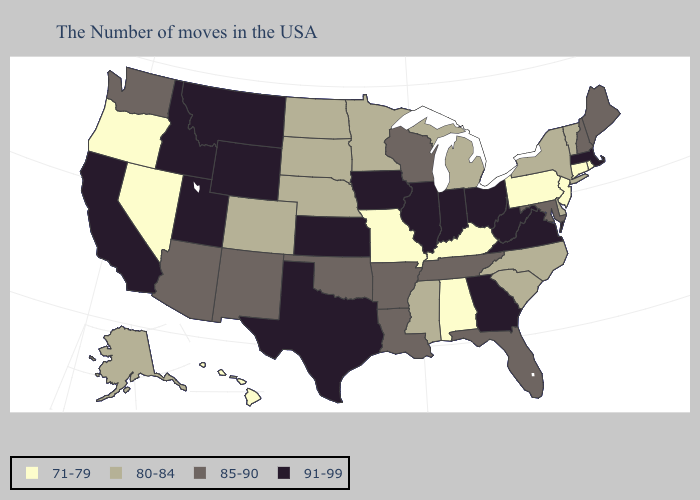Does Hawaii have the lowest value in the West?
Keep it brief. Yes. Does Texas have the lowest value in the USA?
Short answer required. No. Among the states that border Virginia , does West Virginia have the highest value?
Concise answer only. Yes. Among the states that border New Mexico , does Utah have the highest value?
Write a very short answer. Yes. Name the states that have a value in the range 91-99?
Concise answer only. Massachusetts, Virginia, West Virginia, Ohio, Georgia, Indiana, Illinois, Iowa, Kansas, Texas, Wyoming, Utah, Montana, Idaho, California. Name the states that have a value in the range 91-99?
Short answer required. Massachusetts, Virginia, West Virginia, Ohio, Georgia, Indiana, Illinois, Iowa, Kansas, Texas, Wyoming, Utah, Montana, Idaho, California. What is the value of South Dakota?
Answer briefly. 80-84. Among the states that border Indiana , which have the lowest value?
Write a very short answer. Kentucky. What is the value of New Hampshire?
Quick response, please. 85-90. What is the value of Delaware?
Keep it brief. 80-84. What is the lowest value in states that border Missouri?
Short answer required. 71-79. Does Wyoming have the highest value in the USA?
Quick response, please. Yes. Among the states that border Ohio , which have the lowest value?
Quick response, please. Pennsylvania, Kentucky. Among the states that border West Virginia , does Virginia have the highest value?
Give a very brief answer. Yes. Does Utah have the highest value in the West?
Be succinct. Yes. 